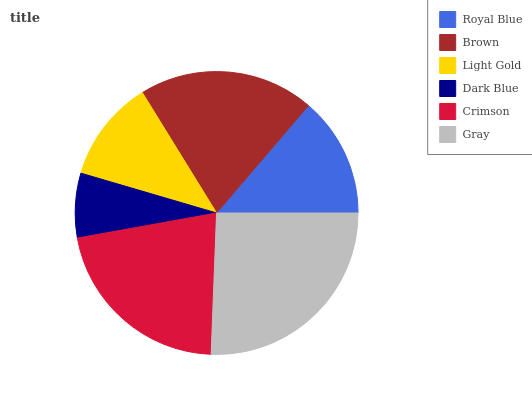Is Dark Blue the minimum?
Answer yes or no. Yes. Is Gray the maximum?
Answer yes or no. Yes. Is Brown the minimum?
Answer yes or no. No. Is Brown the maximum?
Answer yes or no. No. Is Brown greater than Royal Blue?
Answer yes or no. Yes. Is Royal Blue less than Brown?
Answer yes or no. Yes. Is Royal Blue greater than Brown?
Answer yes or no. No. Is Brown less than Royal Blue?
Answer yes or no. No. Is Brown the high median?
Answer yes or no. Yes. Is Royal Blue the low median?
Answer yes or no. Yes. Is Royal Blue the high median?
Answer yes or no. No. Is Brown the low median?
Answer yes or no. No. 